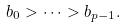<formula> <loc_0><loc_0><loc_500><loc_500>b _ { 0 } > \cdots > b _ { p - 1 } .</formula> 